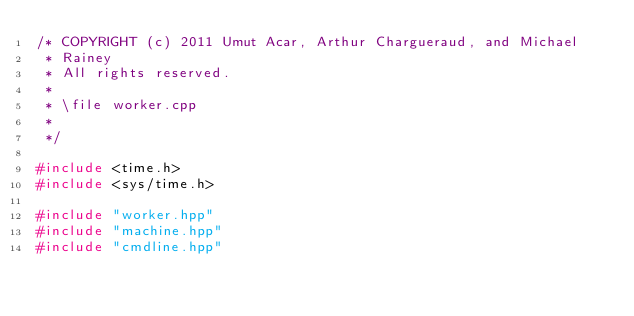<code> <loc_0><loc_0><loc_500><loc_500><_C++_>/* COPYRIGHT (c) 2011 Umut Acar, Arthur Chargueraud, and Michael
 * Rainey
 * All rights reserved.
 *
 * \file worker.cpp
 * 
 */

#include <time.h>
#include <sys/time.h>

#include "worker.hpp"
#include "machine.hpp"
#include "cmdline.hpp"</code> 